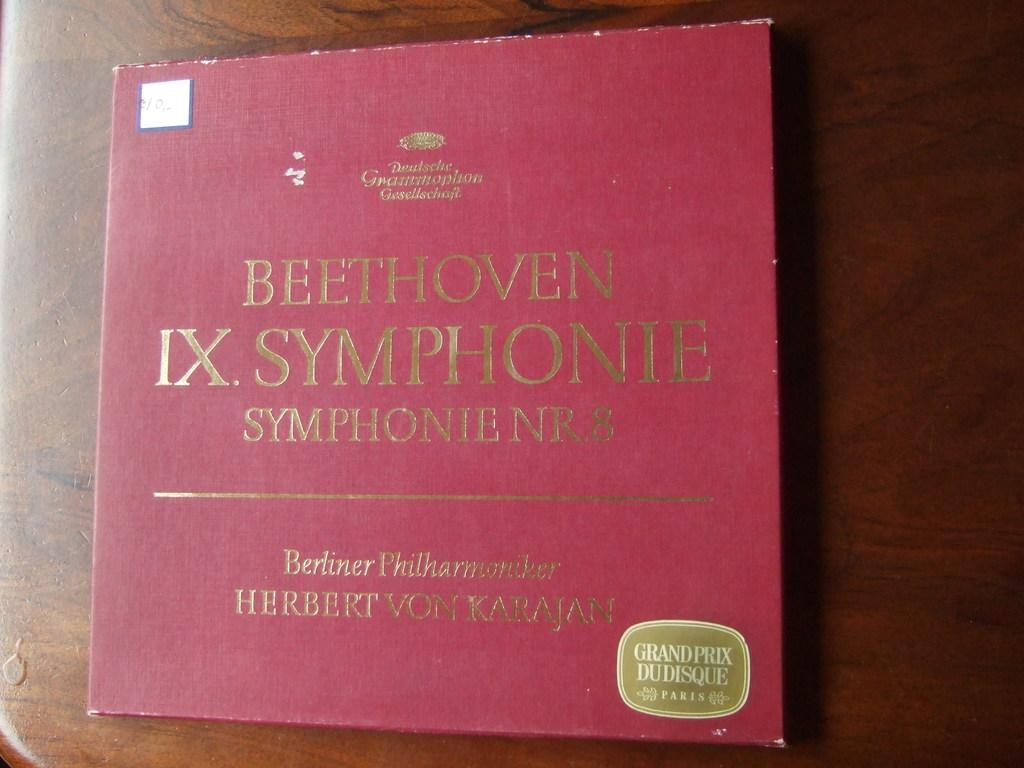What color is the book in the image? The book in the image is red. What type of surface is the book resting on? The book is on a wooden surface. What type of comfort can be found on the coast in the image? There is no coast or comfort mentioned in the image; it only features a red color book on a wooden surface. 